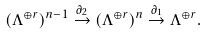Convert formula to latex. <formula><loc_0><loc_0><loc_500><loc_500>( \Lambda ^ { \oplus r } ) ^ { n - 1 } \stackrel { \partial _ { 2 } } \to ( \Lambda ^ { \oplus r } ) ^ { n } \stackrel { \partial _ { 1 } } \to \Lambda ^ { \oplus r } .</formula> 